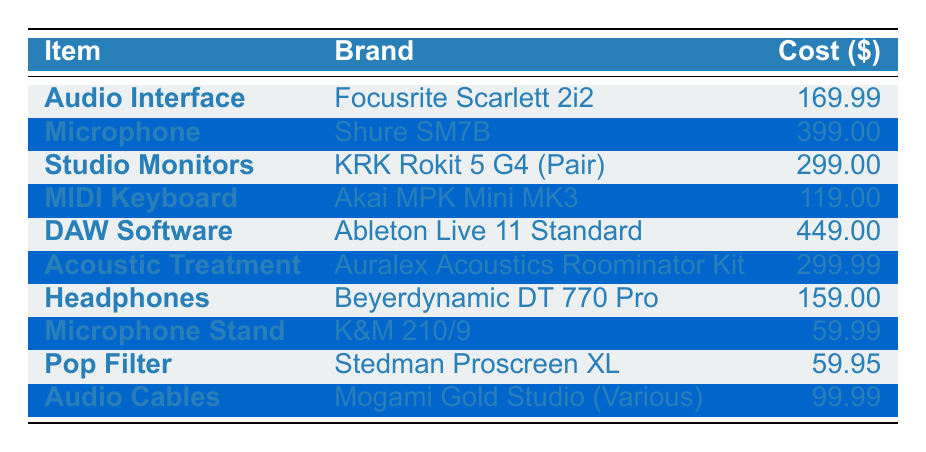What is the cost of the Shure SM7B microphone? The table lists the cost of the Shure SM7B microphone under the "Cost" column. The value associated with it is 399.00.
Answer: 399.00 Which item has the highest cost? By examining the "Cost" column for each item, the DAW Software (Ableton Live 11 Standard) costs 449.00, which is higher than any other item listed.
Answer: DAW Software (Ableton Live 11 Standard) What is the total cost of audio equipment listed in the table? To find the total cost, I add together the costs of all items: 169.99 + 399.00 + 299.00 + 119.00 + 449.00 + 299.99 + 159.00 + 59.99 + 59.95 + 99.99 = 1,734.91.
Answer: 1734.91 Is the cost of the acoustic treatment higher than the cost of the MIDI keyboard? The cost of the Acoustic Treatment (299.99) is compared with the cost of the MIDI Keyboard (119.00). Since 299.99 > 119.00, the statement is true.
Answer: Yes What is the average cost of the items in the table? The average is calculated by summing all item costs (1,734.91) and then dividing by the number of items (10). Thus, 1,734.91/10 = 173.49.
Answer: 173.49 Which brands have equipment that costs less than $100? Referring to the "Cost" column, the Microphone Stand (59.99) and Pop Filter (59.95) are the only items under $100. Therefore, brands associated with these items are K&M and Stedman.
Answer: K&M and Stedman What is the difference in cost between the most expensive and the least expensive item? The most expensive item is the DAW Software at 449.00 and the least expensive item is the Microphone Stand at 59.99. The difference is calculated as 449.00 - 59.99 = 389.01.
Answer: 389.01 How much would it cost to purchase an Audio Interface and a MIDI Keyboard together? The cost of the Audio Interface (169.99) is added to the cost of the MIDI Keyboard (119.00). Therefore, 169.99 + 119.00 = 288.99.
Answer: 288.99 Is the total cost of studio monitors and headphones more than $400? The cost of the Studio Monitors (299.00) and Headphones (159.00) is summed to find 299.00 + 159.00 = 458.00, which is indeed more than $400.
Answer: Yes What percentage of the total cost does the microphone account for? The cost of the microphone (399.00) is divided by the total cost (1,734.91) to find its percentage: (399.00 / 1,734.91) * 100 ≈ 23.0%.
Answer: 23.0% 